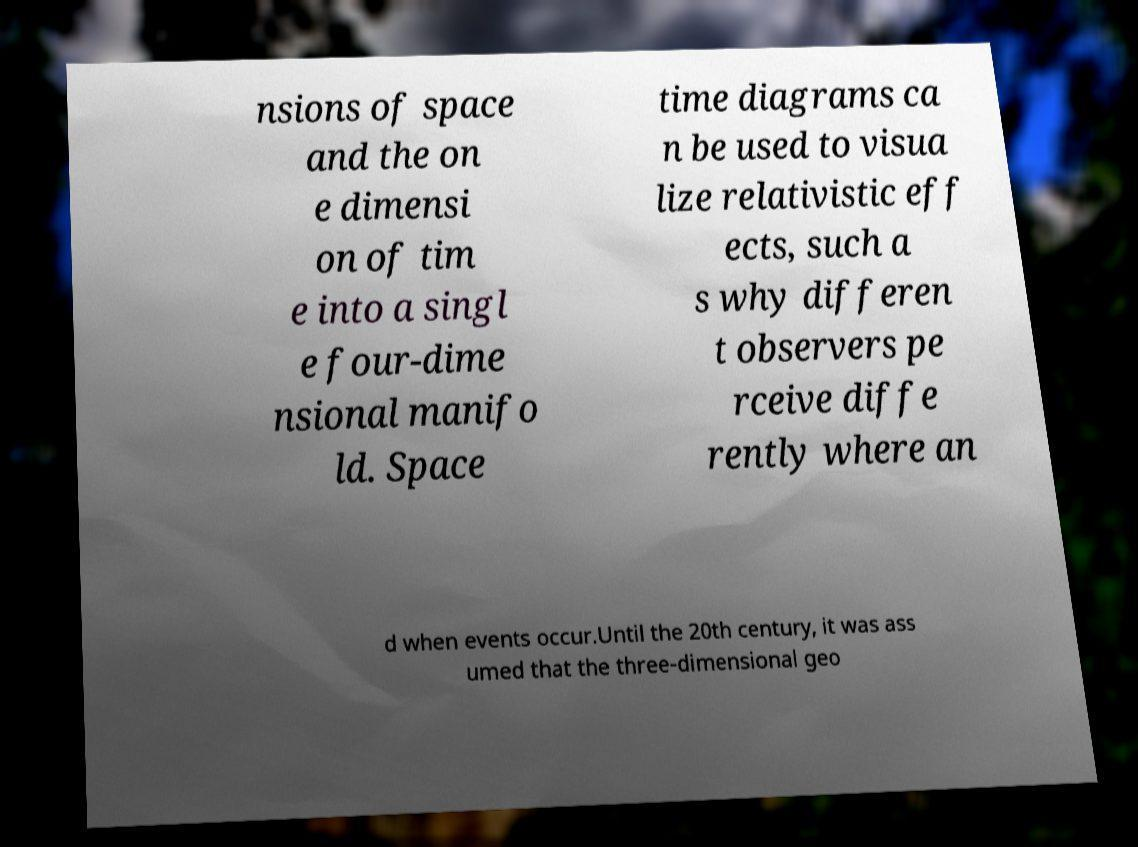Could you assist in decoding the text presented in this image and type it out clearly? nsions of space and the on e dimensi on of tim e into a singl e four-dime nsional manifo ld. Space time diagrams ca n be used to visua lize relativistic eff ects, such a s why differen t observers pe rceive diffe rently where an d when events occur.Until the 20th century, it was ass umed that the three-dimensional geo 